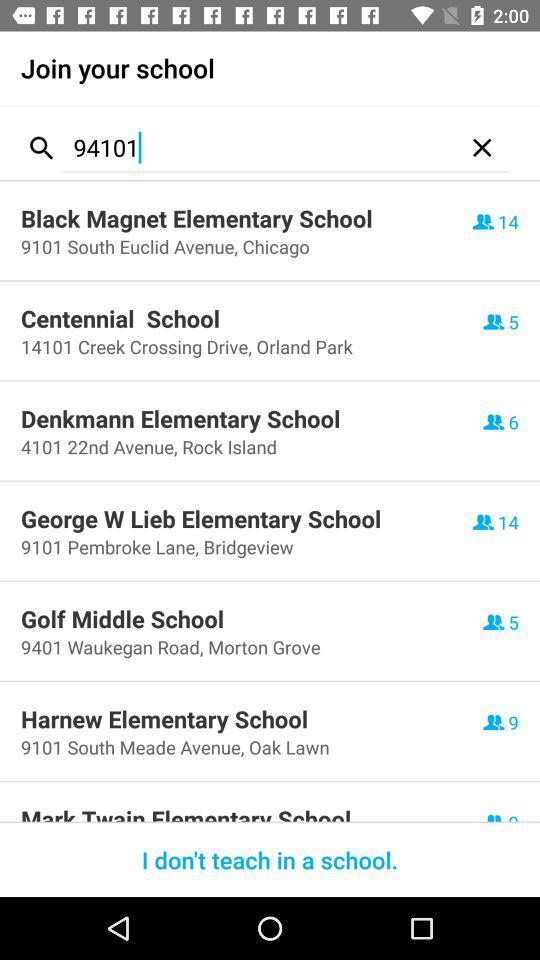Where is Centennial School located? Its location is 14101 Creek Crossing Drive, Orland Park. 